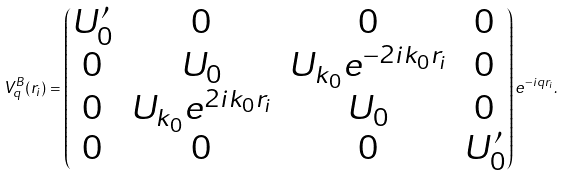<formula> <loc_0><loc_0><loc_500><loc_500>V ^ { B } _ { q } ( r _ { i } ) = \begin{pmatrix} U ^ { \prime } _ { 0 } & 0 & 0 & 0 \\ 0 & U _ { 0 } & U _ { k _ { 0 } } e ^ { - 2 i k _ { 0 } r _ { i } } & 0 \\ 0 & U _ { k _ { 0 } } e ^ { 2 i k _ { 0 } r _ { i } } & U _ { 0 } & 0 \\ 0 & 0 & 0 & U ^ { \prime } _ { 0 } \\ \end{pmatrix} e ^ { - i q r _ { i } } .</formula> 